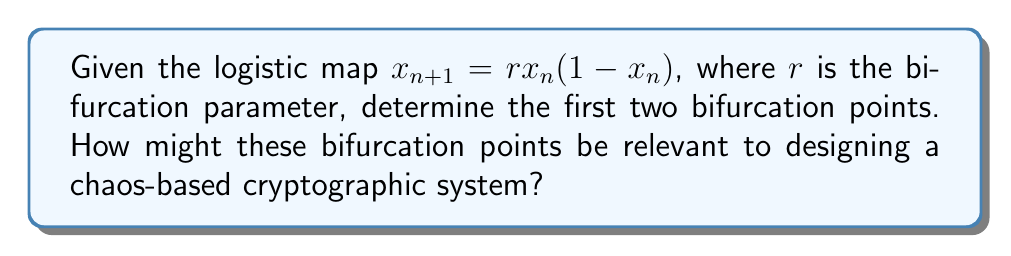Solve this math problem. To find the bifurcation points of the logistic map, we need to analyze the stability of its fixed points:

1. Find the fixed points:
   Let $x^* = rx^*(1-x^*)$
   Solving this equation yields two fixed points:
   $x^*_1 = 0$ and $x^*_2 = 1 - \frac{1}{r}$

2. Analyze stability:
   The stability is determined by the derivative of the map at the fixed points:
   $f'(x) = r(1-2x)$

3. For $x^*_1 = 0$:
   $|f'(0)| = |r| < 1$ when $0 < r < 1$
   The first bifurcation occurs at $r = 1$

4. For $x^*_2 = 1 - \frac{1}{r}$:
   $|f'(1-\frac{1}{r})| = |2-r| < 1$ when $1 < r < 3$
   The second bifurcation occurs at $r = 3$

5. Relevance to cryptography:
   Bifurcation points mark transitions in system behavior, which can be exploited in chaos-based cryptography. The unpredictable nature of the system beyond these points can enhance encryption strength and key generation processes. Additionally, the sensitivity to initial conditions near bifurcation points can be utilized for secure communication protocols.
Answer: $r_1 = 1$, $r_2 = 3$ 